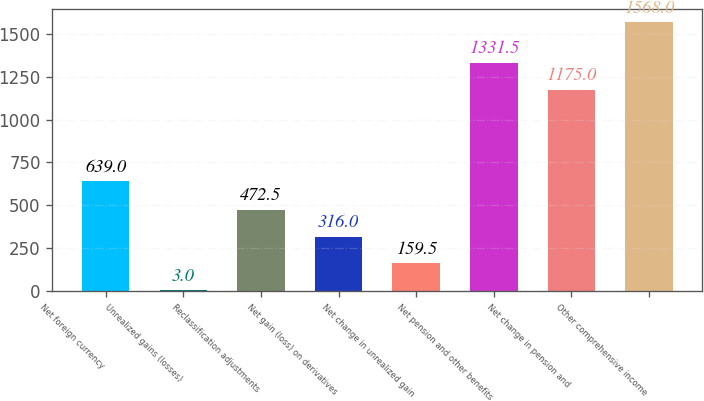Convert chart. <chart><loc_0><loc_0><loc_500><loc_500><bar_chart><fcel>Net foreign currency<fcel>Unrealized gains (losses)<fcel>Reclassification adjustments<fcel>Net gain (loss) on derivatives<fcel>Net change in unrealized gain<fcel>Net pension and other benefits<fcel>Net change in pension and<fcel>Other comprehensive income<nl><fcel>639<fcel>3<fcel>472.5<fcel>316<fcel>159.5<fcel>1331.5<fcel>1175<fcel>1568<nl></chart> 